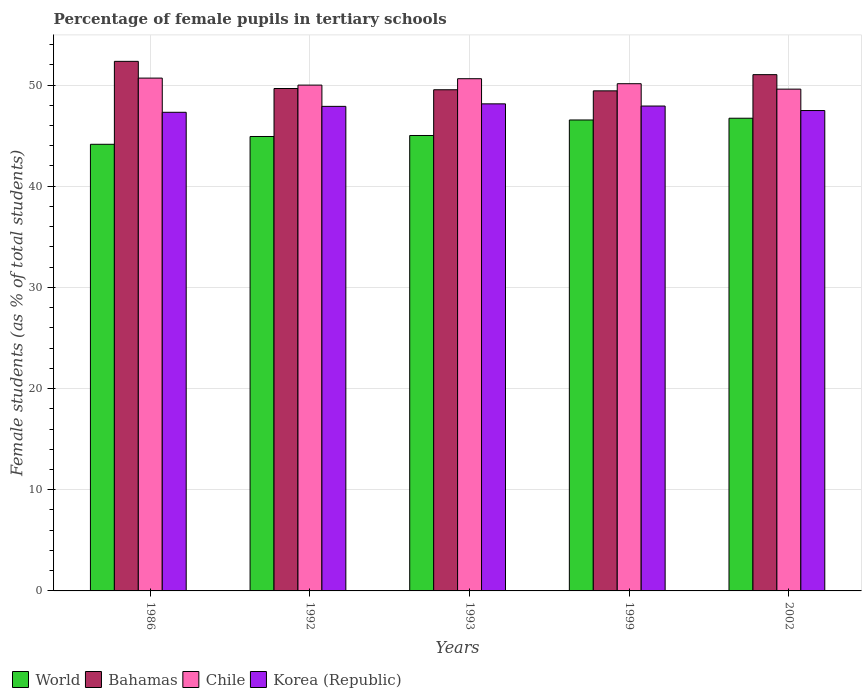Are the number of bars per tick equal to the number of legend labels?
Keep it short and to the point. Yes. Are the number of bars on each tick of the X-axis equal?
Provide a short and direct response. Yes. What is the percentage of female pupils in tertiary schools in Chile in 1986?
Give a very brief answer. 50.68. Across all years, what is the maximum percentage of female pupils in tertiary schools in World?
Your answer should be very brief. 46.72. Across all years, what is the minimum percentage of female pupils in tertiary schools in Korea (Republic)?
Offer a very short reply. 47.31. In which year was the percentage of female pupils in tertiary schools in Chile maximum?
Your answer should be very brief. 1986. In which year was the percentage of female pupils in tertiary schools in Bahamas minimum?
Keep it short and to the point. 1999. What is the total percentage of female pupils in tertiary schools in Bahamas in the graph?
Ensure brevity in your answer.  251.98. What is the difference between the percentage of female pupils in tertiary schools in Korea (Republic) in 1992 and that in 1993?
Your answer should be very brief. -0.25. What is the difference between the percentage of female pupils in tertiary schools in Bahamas in 1992 and the percentage of female pupils in tertiary schools in Korea (Republic) in 2002?
Ensure brevity in your answer.  2.18. What is the average percentage of female pupils in tertiary schools in World per year?
Ensure brevity in your answer.  45.47. In the year 1992, what is the difference between the percentage of female pupils in tertiary schools in World and percentage of female pupils in tertiary schools in Bahamas?
Provide a short and direct response. -4.74. What is the ratio of the percentage of female pupils in tertiary schools in Chile in 1992 to that in 2002?
Your answer should be very brief. 1.01. Is the percentage of female pupils in tertiary schools in Bahamas in 1992 less than that in 2002?
Your response must be concise. Yes. Is the difference between the percentage of female pupils in tertiary schools in World in 1992 and 2002 greater than the difference between the percentage of female pupils in tertiary schools in Bahamas in 1992 and 2002?
Provide a succinct answer. No. What is the difference between the highest and the second highest percentage of female pupils in tertiary schools in World?
Give a very brief answer. 0.17. What is the difference between the highest and the lowest percentage of female pupils in tertiary schools in Bahamas?
Keep it short and to the point. 2.92. In how many years, is the percentage of female pupils in tertiary schools in World greater than the average percentage of female pupils in tertiary schools in World taken over all years?
Your response must be concise. 2. Is the sum of the percentage of female pupils in tertiary schools in Chile in 1992 and 1993 greater than the maximum percentage of female pupils in tertiary schools in World across all years?
Make the answer very short. Yes. What does the 2nd bar from the right in 1992 represents?
Offer a terse response. Chile. Is it the case that in every year, the sum of the percentage of female pupils in tertiary schools in Bahamas and percentage of female pupils in tertiary schools in World is greater than the percentage of female pupils in tertiary schools in Korea (Republic)?
Your answer should be compact. Yes. Are all the bars in the graph horizontal?
Provide a succinct answer. No. How many years are there in the graph?
Make the answer very short. 5. What is the difference between two consecutive major ticks on the Y-axis?
Offer a very short reply. 10. Are the values on the major ticks of Y-axis written in scientific E-notation?
Offer a terse response. No. Does the graph contain any zero values?
Provide a short and direct response. No. Where does the legend appear in the graph?
Give a very brief answer. Bottom left. How are the legend labels stacked?
Your response must be concise. Horizontal. What is the title of the graph?
Ensure brevity in your answer.  Percentage of female pupils in tertiary schools. What is the label or title of the X-axis?
Give a very brief answer. Years. What is the label or title of the Y-axis?
Ensure brevity in your answer.  Female students (as % of total students). What is the Female students (as % of total students) of World in 1986?
Provide a succinct answer. 44.14. What is the Female students (as % of total students) of Bahamas in 1986?
Ensure brevity in your answer.  52.34. What is the Female students (as % of total students) in Chile in 1986?
Offer a terse response. 50.68. What is the Female students (as % of total students) in Korea (Republic) in 1986?
Offer a very short reply. 47.31. What is the Female students (as % of total students) of World in 1992?
Ensure brevity in your answer.  44.91. What is the Female students (as % of total students) of Bahamas in 1992?
Your response must be concise. 49.66. What is the Female students (as % of total students) of Chile in 1992?
Offer a very short reply. 49.99. What is the Female students (as % of total students) in Korea (Republic) in 1992?
Your answer should be very brief. 47.89. What is the Female students (as % of total students) in World in 1993?
Your answer should be compact. 45.01. What is the Female students (as % of total students) in Bahamas in 1993?
Provide a succinct answer. 49.53. What is the Female students (as % of total students) of Chile in 1993?
Give a very brief answer. 50.62. What is the Female students (as % of total students) in Korea (Republic) in 1993?
Give a very brief answer. 48.14. What is the Female students (as % of total students) in World in 1999?
Your answer should be compact. 46.55. What is the Female students (as % of total students) of Bahamas in 1999?
Your answer should be compact. 49.43. What is the Female students (as % of total students) of Chile in 1999?
Ensure brevity in your answer.  50.13. What is the Female students (as % of total students) of Korea (Republic) in 1999?
Make the answer very short. 47.92. What is the Female students (as % of total students) in World in 2002?
Your answer should be compact. 46.72. What is the Female students (as % of total students) of Bahamas in 2002?
Offer a very short reply. 51.03. What is the Female students (as % of total students) in Chile in 2002?
Keep it short and to the point. 49.6. What is the Female students (as % of total students) of Korea (Republic) in 2002?
Your answer should be very brief. 47.48. Across all years, what is the maximum Female students (as % of total students) of World?
Your answer should be very brief. 46.72. Across all years, what is the maximum Female students (as % of total students) of Bahamas?
Give a very brief answer. 52.34. Across all years, what is the maximum Female students (as % of total students) of Chile?
Offer a terse response. 50.68. Across all years, what is the maximum Female students (as % of total students) of Korea (Republic)?
Keep it short and to the point. 48.14. Across all years, what is the minimum Female students (as % of total students) in World?
Offer a terse response. 44.14. Across all years, what is the minimum Female students (as % of total students) in Bahamas?
Offer a very short reply. 49.43. Across all years, what is the minimum Female students (as % of total students) of Chile?
Offer a very short reply. 49.6. Across all years, what is the minimum Female students (as % of total students) of Korea (Republic)?
Provide a succinct answer. 47.31. What is the total Female students (as % of total students) of World in the graph?
Provide a succinct answer. 227.34. What is the total Female students (as % of total students) in Bahamas in the graph?
Your response must be concise. 251.98. What is the total Female students (as % of total students) of Chile in the graph?
Your response must be concise. 251.03. What is the total Female students (as % of total students) in Korea (Republic) in the graph?
Your answer should be compact. 238.74. What is the difference between the Female students (as % of total students) in World in 1986 and that in 1992?
Offer a very short reply. -0.77. What is the difference between the Female students (as % of total students) of Bahamas in 1986 and that in 1992?
Offer a very short reply. 2.68. What is the difference between the Female students (as % of total students) of Chile in 1986 and that in 1992?
Provide a succinct answer. 0.69. What is the difference between the Female students (as % of total students) of Korea (Republic) in 1986 and that in 1992?
Ensure brevity in your answer.  -0.58. What is the difference between the Female students (as % of total students) in World in 1986 and that in 1993?
Make the answer very short. -0.87. What is the difference between the Female students (as % of total students) in Bahamas in 1986 and that in 1993?
Ensure brevity in your answer.  2.81. What is the difference between the Female students (as % of total students) of Chile in 1986 and that in 1993?
Your answer should be very brief. 0.06. What is the difference between the Female students (as % of total students) of Korea (Republic) in 1986 and that in 1993?
Offer a very short reply. -0.83. What is the difference between the Female students (as % of total students) in World in 1986 and that in 1999?
Offer a very short reply. -2.4. What is the difference between the Female students (as % of total students) in Bahamas in 1986 and that in 1999?
Ensure brevity in your answer.  2.92. What is the difference between the Female students (as % of total students) in Chile in 1986 and that in 1999?
Provide a short and direct response. 0.55. What is the difference between the Female students (as % of total students) of Korea (Republic) in 1986 and that in 1999?
Offer a terse response. -0.62. What is the difference between the Female students (as % of total students) in World in 1986 and that in 2002?
Your response must be concise. -2.57. What is the difference between the Female students (as % of total students) in Bahamas in 1986 and that in 2002?
Make the answer very short. 1.31. What is the difference between the Female students (as % of total students) of Chile in 1986 and that in 2002?
Offer a very short reply. 1.09. What is the difference between the Female students (as % of total students) in Korea (Republic) in 1986 and that in 2002?
Your response must be concise. -0.17. What is the difference between the Female students (as % of total students) in World in 1992 and that in 1993?
Offer a very short reply. -0.1. What is the difference between the Female students (as % of total students) in Bahamas in 1992 and that in 1993?
Your answer should be compact. 0.12. What is the difference between the Female students (as % of total students) in Chile in 1992 and that in 1993?
Your answer should be compact. -0.63. What is the difference between the Female students (as % of total students) of Korea (Republic) in 1992 and that in 1993?
Provide a succinct answer. -0.25. What is the difference between the Female students (as % of total students) of World in 1992 and that in 1999?
Give a very brief answer. -1.63. What is the difference between the Female students (as % of total students) in Bahamas in 1992 and that in 1999?
Your answer should be compact. 0.23. What is the difference between the Female students (as % of total students) in Chile in 1992 and that in 1999?
Provide a short and direct response. -0.14. What is the difference between the Female students (as % of total students) of Korea (Republic) in 1992 and that in 1999?
Ensure brevity in your answer.  -0.03. What is the difference between the Female students (as % of total students) in World in 1992 and that in 2002?
Offer a very short reply. -1.8. What is the difference between the Female students (as % of total students) in Bahamas in 1992 and that in 2002?
Offer a very short reply. -1.37. What is the difference between the Female students (as % of total students) of Chile in 1992 and that in 2002?
Make the answer very short. 0.4. What is the difference between the Female students (as % of total students) in Korea (Republic) in 1992 and that in 2002?
Offer a very short reply. 0.41. What is the difference between the Female students (as % of total students) of World in 1993 and that in 1999?
Make the answer very short. -1.53. What is the difference between the Female students (as % of total students) of Bahamas in 1993 and that in 1999?
Give a very brief answer. 0.11. What is the difference between the Female students (as % of total students) in Chile in 1993 and that in 1999?
Your answer should be compact. 0.49. What is the difference between the Female students (as % of total students) in Korea (Republic) in 1993 and that in 1999?
Your response must be concise. 0.22. What is the difference between the Female students (as % of total students) in World in 1993 and that in 2002?
Keep it short and to the point. -1.71. What is the difference between the Female students (as % of total students) in Bahamas in 1993 and that in 2002?
Provide a succinct answer. -1.49. What is the difference between the Female students (as % of total students) in Chile in 1993 and that in 2002?
Your answer should be compact. 1.03. What is the difference between the Female students (as % of total students) of Korea (Republic) in 1993 and that in 2002?
Your answer should be very brief. 0.66. What is the difference between the Female students (as % of total students) in World in 1999 and that in 2002?
Provide a succinct answer. -0.17. What is the difference between the Female students (as % of total students) of Bahamas in 1999 and that in 2002?
Give a very brief answer. -1.6. What is the difference between the Female students (as % of total students) of Chile in 1999 and that in 2002?
Offer a terse response. 0.54. What is the difference between the Female students (as % of total students) in Korea (Republic) in 1999 and that in 2002?
Provide a short and direct response. 0.44. What is the difference between the Female students (as % of total students) of World in 1986 and the Female students (as % of total students) of Bahamas in 1992?
Give a very brief answer. -5.51. What is the difference between the Female students (as % of total students) of World in 1986 and the Female students (as % of total students) of Chile in 1992?
Your answer should be very brief. -5.85. What is the difference between the Female students (as % of total students) of World in 1986 and the Female students (as % of total students) of Korea (Republic) in 1992?
Your response must be concise. -3.75. What is the difference between the Female students (as % of total students) of Bahamas in 1986 and the Female students (as % of total students) of Chile in 1992?
Keep it short and to the point. 2.35. What is the difference between the Female students (as % of total students) in Bahamas in 1986 and the Female students (as % of total students) in Korea (Republic) in 1992?
Make the answer very short. 4.45. What is the difference between the Female students (as % of total students) in Chile in 1986 and the Female students (as % of total students) in Korea (Republic) in 1992?
Your response must be concise. 2.79. What is the difference between the Female students (as % of total students) in World in 1986 and the Female students (as % of total students) in Bahamas in 1993?
Give a very brief answer. -5.39. What is the difference between the Female students (as % of total students) of World in 1986 and the Female students (as % of total students) of Chile in 1993?
Keep it short and to the point. -6.48. What is the difference between the Female students (as % of total students) in World in 1986 and the Female students (as % of total students) in Korea (Republic) in 1993?
Your response must be concise. -4. What is the difference between the Female students (as % of total students) of Bahamas in 1986 and the Female students (as % of total students) of Chile in 1993?
Ensure brevity in your answer.  1.72. What is the difference between the Female students (as % of total students) in Bahamas in 1986 and the Female students (as % of total students) in Korea (Republic) in 1993?
Provide a short and direct response. 4.2. What is the difference between the Female students (as % of total students) in Chile in 1986 and the Female students (as % of total students) in Korea (Republic) in 1993?
Keep it short and to the point. 2.55. What is the difference between the Female students (as % of total students) of World in 1986 and the Female students (as % of total students) of Bahamas in 1999?
Keep it short and to the point. -5.28. What is the difference between the Female students (as % of total students) in World in 1986 and the Female students (as % of total students) in Chile in 1999?
Give a very brief answer. -5.99. What is the difference between the Female students (as % of total students) of World in 1986 and the Female students (as % of total students) of Korea (Republic) in 1999?
Your answer should be compact. -3.78. What is the difference between the Female students (as % of total students) in Bahamas in 1986 and the Female students (as % of total students) in Chile in 1999?
Make the answer very short. 2.21. What is the difference between the Female students (as % of total students) of Bahamas in 1986 and the Female students (as % of total students) of Korea (Republic) in 1999?
Provide a short and direct response. 4.42. What is the difference between the Female students (as % of total students) of Chile in 1986 and the Female students (as % of total students) of Korea (Republic) in 1999?
Offer a terse response. 2.76. What is the difference between the Female students (as % of total students) in World in 1986 and the Female students (as % of total students) in Bahamas in 2002?
Provide a succinct answer. -6.88. What is the difference between the Female students (as % of total students) of World in 1986 and the Female students (as % of total students) of Chile in 2002?
Your answer should be compact. -5.45. What is the difference between the Female students (as % of total students) in World in 1986 and the Female students (as % of total students) in Korea (Republic) in 2002?
Ensure brevity in your answer.  -3.33. What is the difference between the Female students (as % of total students) in Bahamas in 1986 and the Female students (as % of total students) in Chile in 2002?
Offer a terse response. 2.75. What is the difference between the Female students (as % of total students) of Bahamas in 1986 and the Female students (as % of total students) of Korea (Republic) in 2002?
Provide a succinct answer. 4.86. What is the difference between the Female students (as % of total students) in Chile in 1986 and the Female students (as % of total students) in Korea (Republic) in 2002?
Offer a very short reply. 3.21. What is the difference between the Female students (as % of total students) of World in 1992 and the Female students (as % of total students) of Bahamas in 1993?
Provide a short and direct response. -4.62. What is the difference between the Female students (as % of total students) in World in 1992 and the Female students (as % of total students) in Chile in 1993?
Keep it short and to the point. -5.71. What is the difference between the Female students (as % of total students) in World in 1992 and the Female students (as % of total students) in Korea (Republic) in 1993?
Your response must be concise. -3.23. What is the difference between the Female students (as % of total students) of Bahamas in 1992 and the Female students (as % of total students) of Chile in 1993?
Offer a very short reply. -0.97. What is the difference between the Female students (as % of total students) of Bahamas in 1992 and the Female students (as % of total students) of Korea (Republic) in 1993?
Your answer should be compact. 1.52. What is the difference between the Female students (as % of total students) in Chile in 1992 and the Female students (as % of total students) in Korea (Republic) in 1993?
Offer a very short reply. 1.85. What is the difference between the Female students (as % of total students) in World in 1992 and the Female students (as % of total students) in Bahamas in 1999?
Provide a succinct answer. -4.51. What is the difference between the Female students (as % of total students) of World in 1992 and the Female students (as % of total students) of Chile in 1999?
Provide a succinct answer. -5.22. What is the difference between the Female students (as % of total students) of World in 1992 and the Female students (as % of total students) of Korea (Republic) in 1999?
Offer a terse response. -3.01. What is the difference between the Female students (as % of total students) of Bahamas in 1992 and the Female students (as % of total students) of Chile in 1999?
Ensure brevity in your answer.  -0.47. What is the difference between the Female students (as % of total students) in Bahamas in 1992 and the Female students (as % of total students) in Korea (Republic) in 1999?
Your response must be concise. 1.73. What is the difference between the Female students (as % of total students) in Chile in 1992 and the Female students (as % of total students) in Korea (Republic) in 1999?
Your response must be concise. 2.07. What is the difference between the Female students (as % of total students) in World in 1992 and the Female students (as % of total students) in Bahamas in 2002?
Offer a very short reply. -6.11. What is the difference between the Female students (as % of total students) of World in 1992 and the Female students (as % of total students) of Chile in 2002?
Keep it short and to the point. -4.68. What is the difference between the Female students (as % of total students) in World in 1992 and the Female students (as % of total students) in Korea (Republic) in 2002?
Provide a short and direct response. -2.56. What is the difference between the Female students (as % of total students) of Bahamas in 1992 and the Female students (as % of total students) of Chile in 2002?
Your answer should be very brief. 0.06. What is the difference between the Female students (as % of total students) of Bahamas in 1992 and the Female students (as % of total students) of Korea (Republic) in 2002?
Keep it short and to the point. 2.18. What is the difference between the Female students (as % of total students) of Chile in 1992 and the Female students (as % of total students) of Korea (Republic) in 2002?
Ensure brevity in your answer.  2.51. What is the difference between the Female students (as % of total students) of World in 1993 and the Female students (as % of total students) of Bahamas in 1999?
Your response must be concise. -4.41. What is the difference between the Female students (as % of total students) in World in 1993 and the Female students (as % of total students) in Chile in 1999?
Provide a succinct answer. -5.12. What is the difference between the Female students (as % of total students) in World in 1993 and the Female students (as % of total students) in Korea (Republic) in 1999?
Keep it short and to the point. -2.91. What is the difference between the Female students (as % of total students) of Bahamas in 1993 and the Female students (as % of total students) of Chile in 1999?
Your response must be concise. -0.6. What is the difference between the Female students (as % of total students) in Bahamas in 1993 and the Female students (as % of total students) in Korea (Republic) in 1999?
Your answer should be compact. 1.61. What is the difference between the Female students (as % of total students) in Chile in 1993 and the Female students (as % of total students) in Korea (Republic) in 1999?
Your answer should be very brief. 2.7. What is the difference between the Female students (as % of total students) of World in 1993 and the Female students (as % of total students) of Bahamas in 2002?
Your answer should be very brief. -6.01. What is the difference between the Female students (as % of total students) in World in 1993 and the Female students (as % of total students) in Chile in 2002?
Keep it short and to the point. -4.58. What is the difference between the Female students (as % of total students) in World in 1993 and the Female students (as % of total students) in Korea (Republic) in 2002?
Ensure brevity in your answer.  -2.47. What is the difference between the Female students (as % of total students) of Bahamas in 1993 and the Female students (as % of total students) of Chile in 2002?
Keep it short and to the point. -0.06. What is the difference between the Female students (as % of total students) in Bahamas in 1993 and the Female students (as % of total students) in Korea (Republic) in 2002?
Keep it short and to the point. 2.05. What is the difference between the Female students (as % of total students) of Chile in 1993 and the Female students (as % of total students) of Korea (Republic) in 2002?
Provide a succinct answer. 3.15. What is the difference between the Female students (as % of total students) in World in 1999 and the Female students (as % of total students) in Bahamas in 2002?
Offer a terse response. -4.48. What is the difference between the Female students (as % of total students) of World in 1999 and the Female students (as % of total students) of Chile in 2002?
Make the answer very short. -3.05. What is the difference between the Female students (as % of total students) in World in 1999 and the Female students (as % of total students) in Korea (Republic) in 2002?
Provide a succinct answer. -0.93. What is the difference between the Female students (as % of total students) of Bahamas in 1999 and the Female students (as % of total students) of Chile in 2002?
Your answer should be compact. -0.17. What is the difference between the Female students (as % of total students) of Bahamas in 1999 and the Female students (as % of total students) of Korea (Republic) in 2002?
Provide a short and direct response. 1.95. What is the difference between the Female students (as % of total students) of Chile in 1999 and the Female students (as % of total students) of Korea (Republic) in 2002?
Provide a succinct answer. 2.65. What is the average Female students (as % of total students) of World per year?
Ensure brevity in your answer.  45.47. What is the average Female students (as % of total students) of Bahamas per year?
Give a very brief answer. 50.4. What is the average Female students (as % of total students) of Chile per year?
Offer a terse response. 50.21. What is the average Female students (as % of total students) of Korea (Republic) per year?
Offer a very short reply. 47.75. In the year 1986, what is the difference between the Female students (as % of total students) in World and Female students (as % of total students) in Bahamas?
Give a very brief answer. -8.2. In the year 1986, what is the difference between the Female students (as % of total students) in World and Female students (as % of total students) in Chile?
Ensure brevity in your answer.  -6.54. In the year 1986, what is the difference between the Female students (as % of total students) of World and Female students (as % of total students) of Korea (Republic)?
Give a very brief answer. -3.16. In the year 1986, what is the difference between the Female students (as % of total students) in Bahamas and Female students (as % of total students) in Chile?
Ensure brevity in your answer.  1.66. In the year 1986, what is the difference between the Female students (as % of total students) of Bahamas and Female students (as % of total students) of Korea (Republic)?
Provide a short and direct response. 5.03. In the year 1986, what is the difference between the Female students (as % of total students) of Chile and Female students (as % of total students) of Korea (Republic)?
Give a very brief answer. 3.38. In the year 1992, what is the difference between the Female students (as % of total students) of World and Female students (as % of total students) of Bahamas?
Your response must be concise. -4.74. In the year 1992, what is the difference between the Female students (as % of total students) in World and Female students (as % of total students) in Chile?
Your answer should be very brief. -5.08. In the year 1992, what is the difference between the Female students (as % of total students) in World and Female students (as % of total students) in Korea (Republic)?
Make the answer very short. -2.98. In the year 1992, what is the difference between the Female students (as % of total students) of Bahamas and Female students (as % of total students) of Chile?
Offer a terse response. -0.34. In the year 1992, what is the difference between the Female students (as % of total students) of Bahamas and Female students (as % of total students) of Korea (Republic)?
Keep it short and to the point. 1.77. In the year 1992, what is the difference between the Female students (as % of total students) of Chile and Female students (as % of total students) of Korea (Republic)?
Provide a short and direct response. 2.1. In the year 1993, what is the difference between the Female students (as % of total students) in World and Female students (as % of total students) in Bahamas?
Your answer should be compact. -4.52. In the year 1993, what is the difference between the Female students (as % of total students) in World and Female students (as % of total students) in Chile?
Your answer should be compact. -5.61. In the year 1993, what is the difference between the Female students (as % of total students) in World and Female students (as % of total students) in Korea (Republic)?
Your answer should be very brief. -3.13. In the year 1993, what is the difference between the Female students (as % of total students) of Bahamas and Female students (as % of total students) of Chile?
Ensure brevity in your answer.  -1.09. In the year 1993, what is the difference between the Female students (as % of total students) in Bahamas and Female students (as % of total students) in Korea (Republic)?
Ensure brevity in your answer.  1.39. In the year 1993, what is the difference between the Female students (as % of total students) in Chile and Female students (as % of total students) in Korea (Republic)?
Your answer should be compact. 2.49. In the year 1999, what is the difference between the Female students (as % of total students) of World and Female students (as % of total students) of Bahamas?
Make the answer very short. -2.88. In the year 1999, what is the difference between the Female students (as % of total students) in World and Female students (as % of total students) in Chile?
Make the answer very short. -3.58. In the year 1999, what is the difference between the Female students (as % of total students) in World and Female students (as % of total students) in Korea (Republic)?
Provide a short and direct response. -1.38. In the year 1999, what is the difference between the Female students (as % of total students) of Bahamas and Female students (as % of total students) of Chile?
Give a very brief answer. -0.71. In the year 1999, what is the difference between the Female students (as % of total students) in Bahamas and Female students (as % of total students) in Korea (Republic)?
Provide a short and direct response. 1.5. In the year 1999, what is the difference between the Female students (as % of total students) of Chile and Female students (as % of total students) of Korea (Republic)?
Provide a short and direct response. 2.21. In the year 2002, what is the difference between the Female students (as % of total students) of World and Female students (as % of total students) of Bahamas?
Keep it short and to the point. -4.31. In the year 2002, what is the difference between the Female students (as % of total students) in World and Female students (as % of total students) in Chile?
Your answer should be very brief. -2.88. In the year 2002, what is the difference between the Female students (as % of total students) in World and Female students (as % of total students) in Korea (Republic)?
Provide a short and direct response. -0.76. In the year 2002, what is the difference between the Female students (as % of total students) in Bahamas and Female students (as % of total students) in Chile?
Your answer should be compact. 1.43. In the year 2002, what is the difference between the Female students (as % of total students) in Bahamas and Female students (as % of total students) in Korea (Republic)?
Provide a short and direct response. 3.55. In the year 2002, what is the difference between the Female students (as % of total students) of Chile and Female students (as % of total students) of Korea (Republic)?
Your answer should be compact. 2.12. What is the ratio of the Female students (as % of total students) in World in 1986 to that in 1992?
Give a very brief answer. 0.98. What is the ratio of the Female students (as % of total students) in Bahamas in 1986 to that in 1992?
Offer a very short reply. 1.05. What is the ratio of the Female students (as % of total students) in Chile in 1986 to that in 1992?
Your answer should be very brief. 1.01. What is the ratio of the Female students (as % of total students) in World in 1986 to that in 1993?
Ensure brevity in your answer.  0.98. What is the ratio of the Female students (as % of total students) of Bahamas in 1986 to that in 1993?
Make the answer very short. 1.06. What is the ratio of the Female students (as % of total students) of Chile in 1986 to that in 1993?
Make the answer very short. 1. What is the ratio of the Female students (as % of total students) of Korea (Republic) in 1986 to that in 1993?
Your answer should be very brief. 0.98. What is the ratio of the Female students (as % of total students) in World in 1986 to that in 1999?
Provide a succinct answer. 0.95. What is the ratio of the Female students (as % of total students) in Bahamas in 1986 to that in 1999?
Provide a short and direct response. 1.06. What is the ratio of the Female students (as % of total students) in Chile in 1986 to that in 1999?
Your answer should be compact. 1.01. What is the ratio of the Female students (as % of total students) in Korea (Republic) in 1986 to that in 1999?
Provide a short and direct response. 0.99. What is the ratio of the Female students (as % of total students) in World in 1986 to that in 2002?
Your answer should be compact. 0.94. What is the ratio of the Female students (as % of total students) in Bahamas in 1986 to that in 2002?
Offer a very short reply. 1.03. What is the ratio of the Female students (as % of total students) in World in 1992 to that in 1993?
Keep it short and to the point. 1. What is the ratio of the Female students (as % of total students) in Bahamas in 1992 to that in 1993?
Provide a succinct answer. 1. What is the ratio of the Female students (as % of total students) in Chile in 1992 to that in 1993?
Keep it short and to the point. 0.99. What is the ratio of the Female students (as % of total students) in Korea (Republic) in 1992 to that in 1993?
Your response must be concise. 0.99. What is the ratio of the Female students (as % of total students) in World in 1992 to that in 1999?
Offer a very short reply. 0.96. What is the ratio of the Female students (as % of total students) of Chile in 1992 to that in 1999?
Your response must be concise. 1. What is the ratio of the Female students (as % of total students) in Korea (Republic) in 1992 to that in 1999?
Give a very brief answer. 1. What is the ratio of the Female students (as % of total students) of World in 1992 to that in 2002?
Make the answer very short. 0.96. What is the ratio of the Female students (as % of total students) in Bahamas in 1992 to that in 2002?
Ensure brevity in your answer.  0.97. What is the ratio of the Female students (as % of total students) of Chile in 1992 to that in 2002?
Keep it short and to the point. 1.01. What is the ratio of the Female students (as % of total students) in Korea (Republic) in 1992 to that in 2002?
Ensure brevity in your answer.  1.01. What is the ratio of the Female students (as % of total students) in World in 1993 to that in 1999?
Provide a short and direct response. 0.97. What is the ratio of the Female students (as % of total students) of Bahamas in 1993 to that in 1999?
Your response must be concise. 1. What is the ratio of the Female students (as % of total students) in Chile in 1993 to that in 1999?
Give a very brief answer. 1.01. What is the ratio of the Female students (as % of total students) of Korea (Republic) in 1993 to that in 1999?
Offer a terse response. 1. What is the ratio of the Female students (as % of total students) of World in 1993 to that in 2002?
Your response must be concise. 0.96. What is the ratio of the Female students (as % of total students) of Bahamas in 1993 to that in 2002?
Make the answer very short. 0.97. What is the ratio of the Female students (as % of total students) of Chile in 1993 to that in 2002?
Make the answer very short. 1.02. What is the ratio of the Female students (as % of total students) of Korea (Republic) in 1993 to that in 2002?
Make the answer very short. 1.01. What is the ratio of the Female students (as % of total students) in World in 1999 to that in 2002?
Your answer should be very brief. 1. What is the ratio of the Female students (as % of total students) in Bahamas in 1999 to that in 2002?
Keep it short and to the point. 0.97. What is the ratio of the Female students (as % of total students) of Chile in 1999 to that in 2002?
Your answer should be very brief. 1.01. What is the ratio of the Female students (as % of total students) of Korea (Republic) in 1999 to that in 2002?
Your answer should be compact. 1.01. What is the difference between the highest and the second highest Female students (as % of total students) in World?
Provide a succinct answer. 0.17. What is the difference between the highest and the second highest Female students (as % of total students) in Bahamas?
Provide a succinct answer. 1.31. What is the difference between the highest and the second highest Female students (as % of total students) of Korea (Republic)?
Give a very brief answer. 0.22. What is the difference between the highest and the lowest Female students (as % of total students) of World?
Provide a short and direct response. 2.57. What is the difference between the highest and the lowest Female students (as % of total students) in Bahamas?
Give a very brief answer. 2.92. What is the difference between the highest and the lowest Female students (as % of total students) of Chile?
Provide a succinct answer. 1.09. What is the difference between the highest and the lowest Female students (as % of total students) in Korea (Republic)?
Offer a terse response. 0.83. 